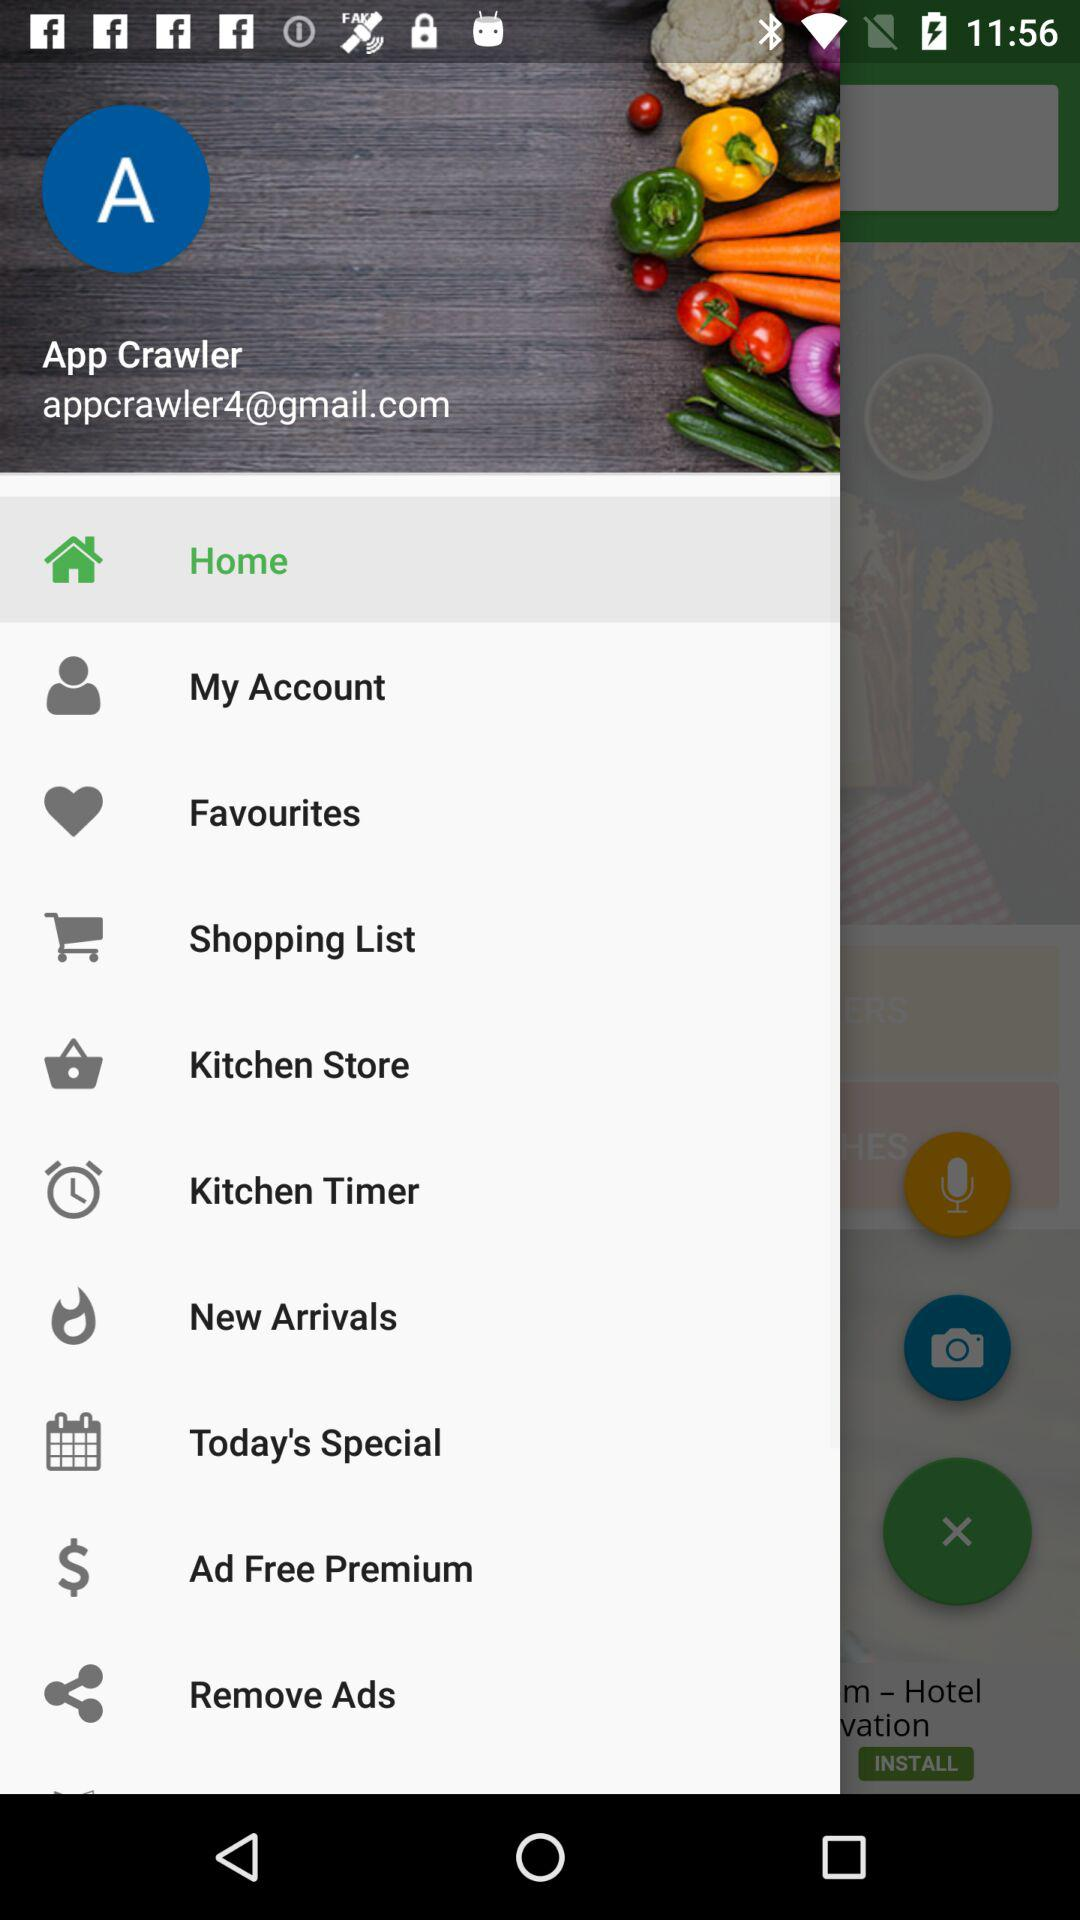What is the name of the user? The name of the user is App Crawler. 